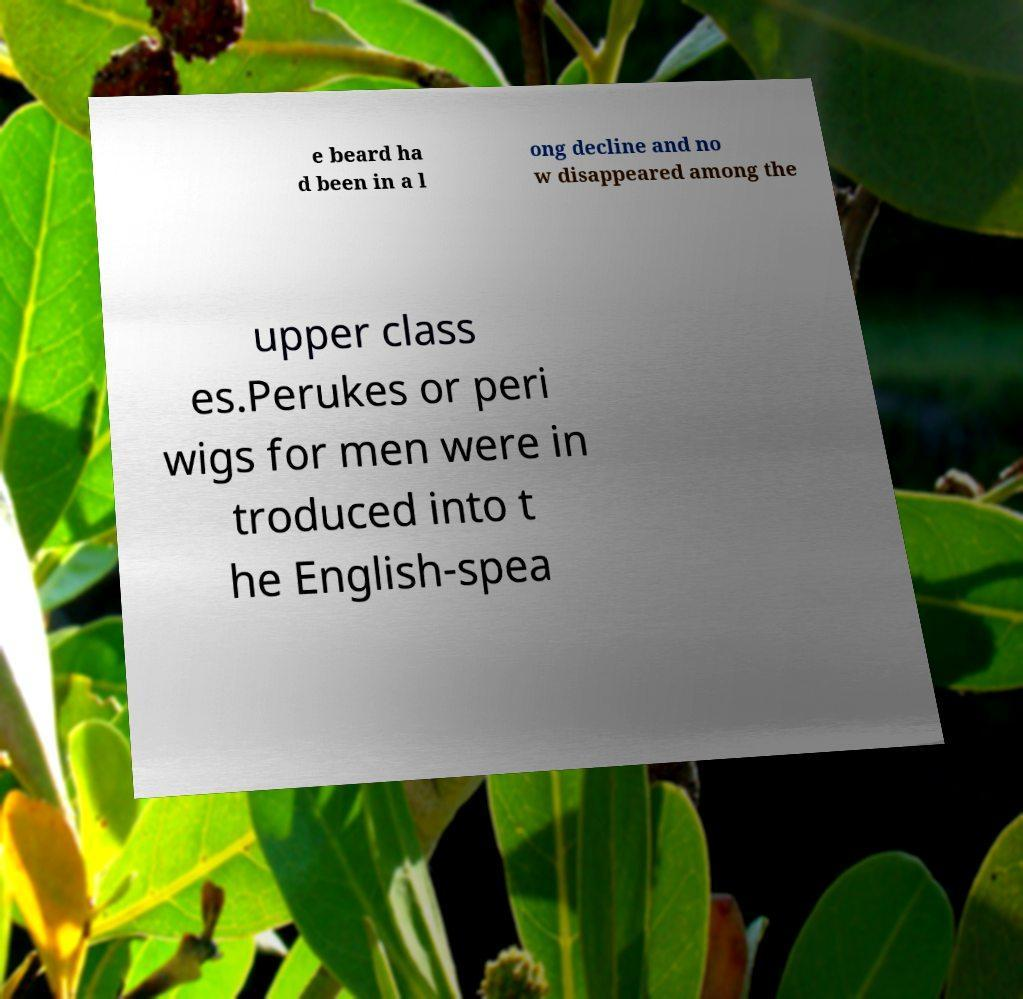What messages or text are displayed in this image? I need them in a readable, typed format. e beard ha d been in a l ong decline and no w disappeared among the upper class es.Perukes or peri wigs for men were in troduced into t he English-spea 